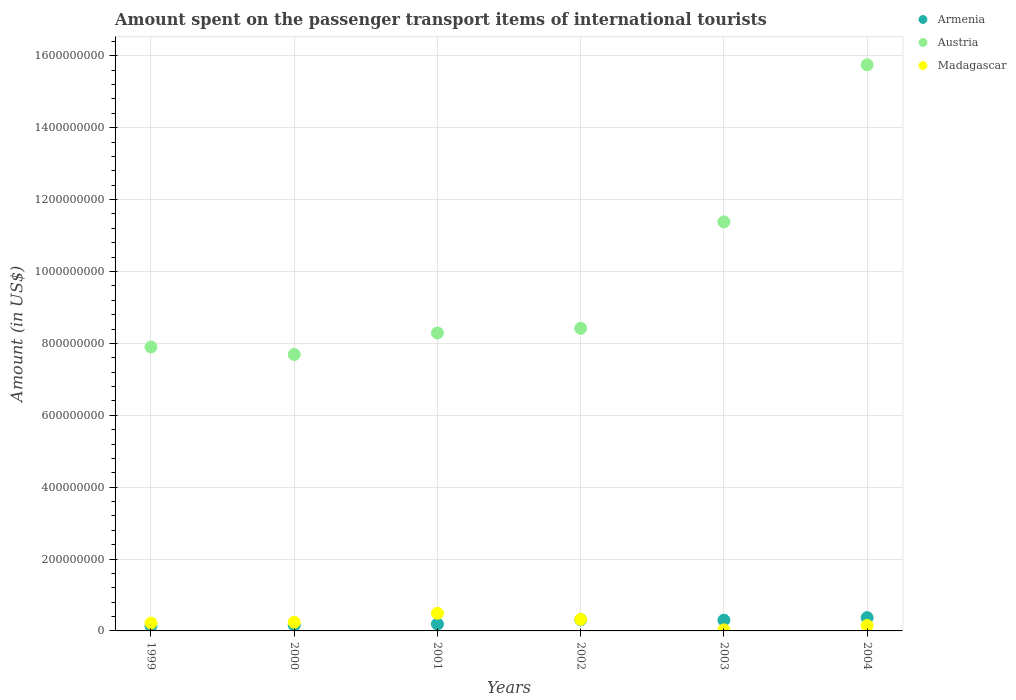Is the number of dotlines equal to the number of legend labels?
Give a very brief answer. Yes. What is the amount spent on the passenger transport items of international tourists in Austria in 2003?
Offer a terse response. 1.14e+09. Across all years, what is the maximum amount spent on the passenger transport items of international tourists in Armenia?
Your answer should be very brief. 3.70e+07. Across all years, what is the minimum amount spent on the passenger transport items of international tourists in Madagascar?
Your response must be concise. 3.00e+06. In which year was the amount spent on the passenger transport items of international tourists in Armenia maximum?
Your answer should be compact. 2004. In which year was the amount spent on the passenger transport items of international tourists in Armenia minimum?
Give a very brief answer. 1999. What is the total amount spent on the passenger transport items of international tourists in Armenia in the graph?
Your answer should be compact. 1.47e+08. What is the difference between the amount spent on the passenger transport items of international tourists in Madagascar in 1999 and that in 2001?
Ensure brevity in your answer.  -2.70e+07. What is the average amount spent on the passenger transport items of international tourists in Austria per year?
Provide a succinct answer. 9.90e+08. In the year 2002, what is the difference between the amount spent on the passenger transport items of international tourists in Austria and amount spent on the passenger transport items of international tourists in Madagascar?
Provide a succinct answer. 8.10e+08. What is the ratio of the amount spent on the passenger transport items of international tourists in Madagascar in 2002 to that in 2004?
Your answer should be compact. 2.13. Is the difference between the amount spent on the passenger transport items of international tourists in Austria in 2001 and 2004 greater than the difference between the amount spent on the passenger transport items of international tourists in Madagascar in 2001 and 2004?
Provide a short and direct response. No. What is the difference between the highest and the second highest amount spent on the passenger transport items of international tourists in Armenia?
Offer a terse response. 6.00e+06. What is the difference between the highest and the lowest amount spent on the passenger transport items of international tourists in Armenia?
Your answer should be compact. 2.30e+07. In how many years, is the amount spent on the passenger transport items of international tourists in Madagascar greater than the average amount spent on the passenger transport items of international tourists in Madagascar taken over all years?
Your response must be concise. 2. Is the sum of the amount spent on the passenger transport items of international tourists in Armenia in 2001 and 2003 greater than the maximum amount spent on the passenger transport items of international tourists in Austria across all years?
Make the answer very short. No. Does the amount spent on the passenger transport items of international tourists in Madagascar monotonically increase over the years?
Make the answer very short. No. How many dotlines are there?
Your response must be concise. 3. How many years are there in the graph?
Your response must be concise. 6. What is the difference between two consecutive major ticks on the Y-axis?
Offer a very short reply. 2.00e+08. How are the legend labels stacked?
Offer a terse response. Vertical. What is the title of the graph?
Keep it short and to the point. Amount spent on the passenger transport items of international tourists. Does "Equatorial Guinea" appear as one of the legend labels in the graph?
Your response must be concise. No. What is the Amount (in US$) in Armenia in 1999?
Give a very brief answer. 1.40e+07. What is the Amount (in US$) of Austria in 1999?
Offer a terse response. 7.90e+08. What is the Amount (in US$) in Madagascar in 1999?
Your response must be concise. 2.20e+07. What is the Amount (in US$) of Armenia in 2000?
Your answer should be compact. 1.60e+07. What is the Amount (in US$) in Austria in 2000?
Keep it short and to the point. 7.69e+08. What is the Amount (in US$) in Madagascar in 2000?
Provide a short and direct response. 2.40e+07. What is the Amount (in US$) of Armenia in 2001?
Offer a very short reply. 1.90e+07. What is the Amount (in US$) of Austria in 2001?
Keep it short and to the point. 8.29e+08. What is the Amount (in US$) in Madagascar in 2001?
Offer a very short reply. 4.90e+07. What is the Amount (in US$) in Armenia in 2002?
Your response must be concise. 3.10e+07. What is the Amount (in US$) of Austria in 2002?
Your answer should be compact. 8.42e+08. What is the Amount (in US$) in Madagascar in 2002?
Your answer should be compact. 3.20e+07. What is the Amount (in US$) of Armenia in 2003?
Keep it short and to the point. 3.00e+07. What is the Amount (in US$) in Austria in 2003?
Give a very brief answer. 1.14e+09. What is the Amount (in US$) of Madagascar in 2003?
Your response must be concise. 3.00e+06. What is the Amount (in US$) in Armenia in 2004?
Give a very brief answer. 3.70e+07. What is the Amount (in US$) in Austria in 2004?
Your answer should be very brief. 1.58e+09. What is the Amount (in US$) in Madagascar in 2004?
Your answer should be compact. 1.50e+07. Across all years, what is the maximum Amount (in US$) in Armenia?
Your answer should be compact. 3.70e+07. Across all years, what is the maximum Amount (in US$) in Austria?
Offer a terse response. 1.58e+09. Across all years, what is the maximum Amount (in US$) in Madagascar?
Make the answer very short. 4.90e+07. Across all years, what is the minimum Amount (in US$) in Armenia?
Make the answer very short. 1.40e+07. Across all years, what is the minimum Amount (in US$) in Austria?
Give a very brief answer. 7.69e+08. What is the total Amount (in US$) of Armenia in the graph?
Your answer should be very brief. 1.47e+08. What is the total Amount (in US$) of Austria in the graph?
Your response must be concise. 5.94e+09. What is the total Amount (in US$) of Madagascar in the graph?
Ensure brevity in your answer.  1.45e+08. What is the difference between the Amount (in US$) in Austria in 1999 and that in 2000?
Keep it short and to the point. 2.10e+07. What is the difference between the Amount (in US$) of Madagascar in 1999 and that in 2000?
Keep it short and to the point. -2.00e+06. What is the difference between the Amount (in US$) of Armenia in 1999 and that in 2001?
Give a very brief answer. -5.00e+06. What is the difference between the Amount (in US$) of Austria in 1999 and that in 2001?
Ensure brevity in your answer.  -3.90e+07. What is the difference between the Amount (in US$) in Madagascar in 1999 and that in 2001?
Provide a succinct answer. -2.70e+07. What is the difference between the Amount (in US$) of Armenia in 1999 and that in 2002?
Provide a short and direct response. -1.70e+07. What is the difference between the Amount (in US$) of Austria in 1999 and that in 2002?
Keep it short and to the point. -5.20e+07. What is the difference between the Amount (in US$) of Madagascar in 1999 and that in 2002?
Your answer should be compact. -1.00e+07. What is the difference between the Amount (in US$) in Armenia in 1999 and that in 2003?
Give a very brief answer. -1.60e+07. What is the difference between the Amount (in US$) of Austria in 1999 and that in 2003?
Give a very brief answer. -3.48e+08. What is the difference between the Amount (in US$) of Madagascar in 1999 and that in 2003?
Your answer should be very brief. 1.90e+07. What is the difference between the Amount (in US$) in Armenia in 1999 and that in 2004?
Provide a short and direct response. -2.30e+07. What is the difference between the Amount (in US$) of Austria in 1999 and that in 2004?
Provide a succinct answer. -7.85e+08. What is the difference between the Amount (in US$) of Madagascar in 1999 and that in 2004?
Ensure brevity in your answer.  7.00e+06. What is the difference between the Amount (in US$) in Armenia in 2000 and that in 2001?
Make the answer very short. -3.00e+06. What is the difference between the Amount (in US$) of Austria in 2000 and that in 2001?
Give a very brief answer. -6.00e+07. What is the difference between the Amount (in US$) in Madagascar in 2000 and that in 2001?
Ensure brevity in your answer.  -2.50e+07. What is the difference between the Amount (in US$) in Armenia in 2000 and that in 2002?
Provide a short and direct response. -1.50e+07. What is the difference between the Amount (in US$) in Austria in 2000 and that in 2002?
Offer a very short reply. -7.30e+07. What is the difference between the Amount (in US$) of Madagascar in 2000 and that in 2002?
Make the answer very short. -8.00e+06. What is the difference between the Amount (in US$) of Armenia in 2000 and that in 2003?
Ensure brevity in your answer.  -1.40e+07. What is the difference between the Amount (in US$) in Austria in 2000 and that in 2003?
Offer a terse response. -3.69e+08. What is the difference between the Amount (in US$) of Madagascar in 2000 and that in 2003?
Make the answer very short. 2.10e+07. What is the difference between the Amount (in US$) in Armenia in 2000 and that in 2004?
Keep it short and to the point. -2.10e+07. What is the difference between the Amount (in US$) of Austria in 2000 and that in 2004?
Give a very brief answer. -8.06e+08. What is the difference between the Amount (in US$) of Madagascar in 2000 and that in 2004?
Give a very brief answer. 9.00e+06. What is the difference between the Amount (in US$) in Armenia in 2001 and that in 2002?
Provide a short and direct response. -1.20e+07. What is the difference between the Amount (in US$) in Austria in 2001 and that in 2002?
Your answer should be very brief. -1.30e+07. What is the difference between the Amount (in US$) of Madagascar in 2001 and that in 2002?
Your response must be concise. 1.70e+07. What is the difference between the Amount (in US$) of Armenia in 2001 and that in 2003?
Your answer should be very brief. -1.10e+07. What is the difference between the Amount (in US$) in Austria in 2001 and that in 2003?
Provide a short and direct response. -3.09e+08. What is the difference between the Amount (in US$) in Madagascar in 2001 and that in 2003?
Offer a very short reply. 4.60e+07. What is the difference between the Amount (in US$) of Armenia in 2001 and that in 2004?
Offer a very short reply. -1.80e+07. What is the difference between the Amount (in US$) of Austria in 2001 and that in 2004?
Offer a very short reply. -7.46e+08. What is the difference between the Amount (in US$) of Madagascar in 2001 and that in 2004?
Your answer should be very brief. 3.40e+07. What is the difference between the Amount (in US$) in Armenia in 2002 and that in 2003?
Ensure brevity in your answer.  1.00e+06. What is the difference between the Amount (in US$) in Austria in 2002 and that in 2003?
Your answer should be compact. -2.96e+08. What is the difference between the Amount (in US$) of Madagascar in 2002 and that in 2003?
Offer a very short reply. 2.90e+07. What is the difference between the Amount (in US$) of Armenia in 2002 and that in 2004?
Provide a succinct answer. -6.00e+06. What is the difference between the Amount (in US$) of Austria in 2002 and that in 2004?
Ensure brevity in your answer.  -7.33e+08. What is the difference between the Amount (in US$) in Madagascar in 2002 and that in 2004?
Provide a short and direct response. 1.70e+07. What is the difference between the Amount (in US$) of Armenia in 2003 and that in 2004?
Your answer should be very brief. -7.00e+06. What is the difference between the Amount (in US$) in Austria in 2003 and that in 2004?
Offer a terse response. -4.37e+08. What is the difference between the Amount (in US$) of Madagascar in 2003 and that in 2004?
Offer a terse response. -1.20e+07. What is the difference between the Amount (in US$) in Armenia in 1999 and the Amount (in US$) in Austria in 2000?
Provide a succinct answer. -7.55e+08. What is the difference between the Amount (in US$) in Armenia in 1999 and the Amount (in US$) in Madagascar in 2000?
Keep it short and to the point. -1.00e+07. What is the difference between the Amount (in US$) in Austria in 1999 and the Amount (in US$) in Madagascar in 2000?
Your answer should be compact. 7.66e+08. What is the difference between the Amount (in US$) of Armenia in 1999 and the Amount (in US$) of Austria in 2001?
Provide a succinct answer. -8.15e+08. What is the difference between the Amount (in US$) of Armenia in 1999 and the Amount (in US$) of Madagascar in 2001?
Keep it short and to the point. -3.50e+07. What is the difference between the Amount (in US$) of Austria in 1999 and the Amount (in US$) of Madagascar in 2001?
Ensure brevity in your answer.  7.41e+08. What is the difference between the Amount (in US$) of Armenia in 1999 and the Amount (in US$) of Austria in 2002?
Your response must be concise. -8.28e+08. What is the difference between the Amount (in US$) of Armenia in 1999 and the Amount (in US$) of Madagascar in 2002?
Ensure brevity in your answer.  -1.80e+07. What is the difference between the Amount (in US$) of Austria in 1999 and the Amount (in US$) of Madagascar in 2002?
Provide a short and direct response. 7.58e+08. What is the difference between the Amount (in US$) in Armenia in 1999 and the Amount (in US$) in Austria in 2003?
Your response must be concise. -1.12e+09. What is the difference between the Amount (in US$) of Armenia in 1999 and the Amount (in US$) of Madagascar in 2003?
Make the answer very short. 1.10e+07. What is the difference between the Amount (in US$) in Austria in 1999 and the Amount (in US$) in Madagascar in 2003?
Make the answer very short. 7.87e+08. What is the difference between the Amount (in US$) of Armenia in 1999 and the Amount (in US$) of Austria in 2004?
Your answer should be very brief. -1.56e+09. What is the difference between the Amount (in US$) in Austria in 1999 and the Amount (in US$) in Madagascar in 2004?
Keep it short and to the point. 7.75e+08. What is the difference between the Amount (in US$) in Armenia in 2000 and the Amount (in US$) in Austria in 2001?
Your answer should be very brief. -8.13e+08. What is the difference between the Amount (in US$) of Armenia in 2000 and the Amount (in US$) of Madagascar in 2001?
Make the answer very short. -3.30e+07. What is the difference between the Amount (in US$) of Austria in 2000 and the Amount (in US$) of Madagascar in 2001?
Your answer should be very brief. 7.20e+08. What is the difference between the Amount (in US$) of Armenia in 2000 and the Amount (in US$) of Austria in 2002?
Keep it short and to the point. -8.26e+08. What is the difference between the Amount (in US$) of Armenia in 2000 and the Amount (in US$) of Madagascar in 2002?
Give a very brief answer. -1.60e+07. What is the difference between the Amount (in US$) in Austria in 2000 and the Amount (in US$) in Madagascar in 2002?
Provide a short and direct response. 7.37e+08. What is the difference between the Amount (in US$) in Armenia in 2000 and the Amount (in US$) in Austria in 2003?
Ensure brevity in your answer.  -1.12e+09. What is the difference between the Amount (in US$) in Armenia in 2000 and the Amount (in US$) in Madagascar in 2003?
Your answer should be compact. 1.30e+07. What is the difference between the Amount (in US$) in Austria in 2000 and the Amount (in US$) in Madagascar in 2003?
Your response must be concise. 7.66e+08. What is the difference between the Amount (in US$) in Armenia in 2000 and the Amount (in US$) in Austria in 2004?
Provide a succinct answer. -1.56e+09. What is the difference between the Amount (in US$) of Armenia in 2000 and the Amount (in US$) of Madagascar in 2004?
Offer a very short reply. 1.00e+06. What is the difference between the Amount (in US$) in Austria in 2000 and the Amount (in US$) in Madagascar in 2004?
Your response must be concise. 7.54e+08. What is the difference between the Amount (in US$) of Armenia in 2001 and the Amount (in US$) of Austria in 2002?
Your answer should be very brief. -8.23e+08. What is the difference between the Amount (in US$) of Armenia in 2001 and the Amount (in US$) of Madagascar in 2002?
Make the answer very short. -1.30e+07. What is the difference between the Amount (in US$) in Austria in 2001 and the Amount (in US$) in Madagascar in 2002?
Offer a very short reply. 7.97e+08. What is the difference between the Amount (in US$) in Armenia in 2001 and the Amount (in US$) in Austria in 2003?
Give a very brief answer. -1.12e+09. What is the difference between the Amount (in US$) in Armenia in 2001 and the Amount (in US$) in Madagascar in 2003?
Offer a terse response. 1.60e+07. What is the difference between the Amount (in US$) in Austria in 2001 and the Amount (in US$) in Madagascar in 2003?
Keep it short and to the point. 8.26e+08. What is the difference between the Amount (in US$) of Armenia in 2001 and the Amount (in US$) of Austria in 2004?
Offer a terse response. -1.56e+09. What is the difference between the Amount (in US$) of Austria in 2001 and the Amount (in US$) of Madagascar in 2004?
Your response must be concise. 8.14e+08. What is the difference between the Amount (in US$) of Armenia in 2002 and the Amount (in US$) of Austria in 2003?
Make the answer very short. -1.11e+09. What is the difference between the Amount (in US$) of Armenia in 2002 and the Amount (in US$) of Madagascar in 2003?
Make the answer very short. 2.80e+07. What is the difference between the Amount (in US$) of Austria in 2002 and the Amount (in US$) of Madagascar in 2003?
Make the answer very short. 8.39e+08. What is the difference between the Amount (in US$) in Armenia in 2002 and the Amount (in US$) in Austria in 2004?
Your answer should be very brief. -1.54e+09. What is the difference between the Amount (in US$) in Armenia in 2002 and the Amount (in US$) in Madagascar in 2004?
Offer a very short reply. 1.60e+07. What is the difference between the Amount (in US$) of Austria in 2002 and the Amount (in US$) of Madagascar in 2004?
Your answer should be compact. 8.27e+08. What is the difference between the Amount (in US$) of Armenia in 2003 and the Amount (in US$) of Austria in 2004?
Keep it short and to the point. -1.54e+09. What is the difference between the Amount (in US$) of Armenia in 2003 and the Amount (in US$) of Madagascar in 2004?
Your answer should be compact. 1.50e+07. What is the difference between the Amount (in US$) of Austria in 2003 and the Amount (in US$) of Madagascar in 2004?
Give a very brief answer. 1.12e+09. What is the average Amount (in US$) of Armenia per year?
Ensure brevity in your answer.  2.45e+07. What is the average Amount (in US$) in Austria per year?
Provide a succinct answer. 9.90e+08. What is the average Amount (in US$) of Madagascar per year?
Make the answer very short. 2.42e+07. In the year 1999, what is the difference between the Amount (in US$) in Armenia and Amount (in US$) in Austria?
Make the answer very short. -7.76e+08. In the year 1999, what is the difference between the Amount (in US$) in Armenia and Amount (in US$) in Madagascar?
Give a very brief answer. -8.00e+06. In the year 1999, what is the difference between the Amount (in US$) of Austria and Amount (in US$) of Madagascar?
Your answer should be very brief. 7.68e+08. In the year 2000, what is the difference between the Amount (in US$) in Armenia and Amount (in US$) in Austria?
Your answer should be compact. -7.53e+08. In the year 2000, what is the difference between the Amount (in US$) of Armenia and Amount (in US$) of Madagascar?
Your response must be concise. -8.00e+06. In the year 2000, what is the difference between the Amount (in US$) in Austria and Amount (in US$) in Madagascar?
Make the answer very short. 7.45e+08. In the year 2001, what is the difference between the Amount (in US$) of Armenia and Amount (in US$) of Austria?
Provide a succinct answer. -8.10e+08. In the year 2001, what is the difference between the Amount (in US$) of Armenia and Amount (in US$) of Madagascar?
Your response must be concise. -3.00e+07. In the year 2001, what is the difference between the Amount (in US$) of Austria and Amount (in US$) of Madagascar?
Make the answer very short. 7.80e+08. In the year 2002, what is the difference between the Amount (in US$) of Armenia and Amount (in US$) of Austria?
Give a very brief answer. -8.11e+08. In the year 2002, what is the difference between the Amount (in US$) in Armenia and Amount (in US$) in Madagascar?
Give a very brief answer. -1.00e+06. In the year 2002, what is the difference between the Amount (in US$) of Austria and Amount (in US$) of Madagascar?
Provide a short and direct response. 8.10e+08. In the year 2003, what is the difference between the Amount (in US$) of Armenia and Amount (in US$) of Austria?
Offer a terse response. -1.11e+09. In the year 2003, what is the difference between the Amount (in US$) of Armenia and Amount (in US$) of Madagascar?
Make the answer very short. 2.70e+07. In the year 2003, what is the difference between the Amount (in US$) of Austria and Amount (in US$) of Madagascar?
Make the answer very short. 1.14e+09. In the year 2004, what is the difference between the Amount (in US$) of Armenia and Amount (in US$) of Austria?
Ensure brevity in your answer.  -1.54e+09. In the year 2004, what is the difference between the Amount (in US$) in Armenia and Amount (in US$) in Madagascar?
Offer a terse response. 2.20e+07. In the year 2004, what is the difference between the Amount (in US$) of Austria and Amount (in US$) of Madagascar?
Provide a succinct answer. 1.56e+09. What is the ratio of the Amount (in US$) in Armenia in 1999 to that in 2000?
Give a very brief answer. 0.88. What is the ratio of the Amount (in US$) in Austria in 1999 to that in 2000?
Ensure brevity in your answer.  1.03. What is the ratio of the Amount (in US$) of Armenia in 1999 to that in 2001?
Offer a very short reply. 0.74. What is the ratio of the Amount (in US$) in Austria in 1999 to that in 2001?
Offer a terse response. 0.95. What is the ratio of the Amount (in US$) of Madagascar in 1999 to that in 2001?
Provide a succinct answer. 0.45. What is the ratio of the Amount (in US$) in Armenia in 1999 to that in 2002?
Make the answer very short. 0.45. What is the ratio of the Amount (in US$) in Austria in 1999 to that in 2002?
Provide a succinct answer. 0.94. What is the ratio of the Amount (in US$) of Madagascar in 1999 to that in 2002?
Ensure brevity in your answer.  0.69. What is the ratio of the Amount (in US$) of Armenia in 1999 to that in 2003?
Ensure brevity in your answer.  0.47. What is the ratio of the Amount (in US$) in Austria in 1999 to that in 2003?
Provide a short and direct response. 0.69. What is the ratio of the Amount (in US$) of Madagascar in 1999 to that in 2003?
Your answer should be very brief. 7.33. What is the ratio of the Amount (in US$) in Armenia in 1999 to that in 2004?
Your answer should be compact. 0.38. What is the ratio of the Amount (in US$) of Austria in 1999 to that in 2004?
Offer a very short reply. 0.5. What is the ratio of the Amount (in US$) of Madagascar in 1999 to that in 2004?
Offer a very short reply. 1.47. What is the ratio of the Amount (in US$) in Armenia in 2000 to that in 2001?
Provide a short and direct response. 0.84. What is the ratio of the Amount (in US$) in Austria in 2000 to that in 2001?
Your answer should be very brief. 0.93. What is the ratio of the Amount (in US$) of Madagascar in 2000 to that in 2001?
Provide a short and direct response. 0.49. What is the ratio of the Amount (in US$) of Armenia in 2000 to that in 2002?
Your answer should be compact. 0.52. What is the ratio of the Amount (in US$) of Austria in 2000 to that in 2002?
Provide a short and direct response. 0.91. What is the ratio of the Amount (in US$) of Armenia in 2000 to that in 2003?
Offer a terse response. 0.53. What is the ratio of the Amount (in US$) in Austria in 2000 to that in 2003?
Provide a succinct answer. 0.68. What is the ratio of the Amount (in US$) in Madagascar in 2000 to that in 2003?
Offer a terse response. 8. What is the ratio of the Amount (in US$) of Armenia in 2000 to that in 2004?
Keep it short and to the point. 0.43. What is the ratio of the Amount (in US$) of Austria in 2000 to that in 2004?
Provide a short and direct response. 0.49. What is the ratio of the Amount (in US$) of Madagascar in 2000 to that in 2004?
Provide a short and direct response. 1.6. What is the ratio of the Amount (in US$) in Armenia in 2001 to that in 2002?
Give a very brief answer. 0.61. What is the ratio of the Amount (in US$) of Austria in 2001 to that in 2002?
Offer a terse response. 0.98. What is the ratio of the Amount (in US$) in Madagascar in 2001 to that in 2002?
Your answer should be very brief. 1.53. What is the ratio of the Amount (in US$) in Armenia in 2001 to that in 2003?
Provide a succinct answer. 0.63. What is the ratio of the Amount (in US$) in Austria in 2001 to that in 2003?
Offer a very short reply. 0.73. What is the ratio of the Amount (in US$) of Madagascar in 2001 to that in 2003?
Make the answer very short. 16.33. What is the ratio of the Amount (in US$) of Armenia in 2001 to that in 2004?
Offer a terse response. 0.51. What is the ratio of the Amount (in US$) in Austria in 2001 to that in 2004?
Offer a terse response. 0.53. What is the ratio of the Amount (in US$) of Madagascar in 2001 to that in 2004?
Provide a succinct answer. 3.27. What is the ratio of the Amount (in US$) in Armenia in 2002 to that in 2003?
Give a very brief answer. 1.03. What is the ratio of the Amount (in US$) in Austria in 2002 to that in 2003?
Ensure brevity in your answer.  0.74. What is the ratio of the Amount (in US$) of Madagascar in 2002 to that in 2003?
Your response must be concise. 10.67. What is the ratio of the Amount (in US$) in Armenia in 2002 to that in 2004?
Make the answer very short. 0.84. What is the ratio of the Amount (in US$) of Austria in 2002 to that in 2004?
Make the answer very short. 0.53. What is the ratio of the Amount (in US$) in Madagascar in 2002 to that in 2004?
Give a very brief answer. 2.13. What is the ratio of the Amount (in US$) in Armenia in 2003 to that in 2004?
Give a very brief answer. 0.81. What is the ratio of the Amount (in US$) in Austria in 2003 to that in 2004?
Give a very brief answer. 0.72. What is the difference between the highest and the second highest Amount (in US$) of Armenia?
Offer a very short reply. 6.00e+06. What is the difference between the highest and the second highest Amount (in US$) in Austria?
Make the answer very short. 4.37e+08. What is the difference between the highest and the second highest Amount (in US$) of Madagascar?
Make the answer very short. 1.70e+07. What is the difference between the highest and the lowest Amount (in US$) in Armenia?
Ensure brevity in your answer.  2.30e+07. What is the difference between the highest and the lowest Amount (in US$) in Austria?
Ensure brevity in your answer.  8.06e+08. What is the difference between the highest and the lowest Amount (in US$) of Madagascar?
Offer a terse response. 4.60e+07. 